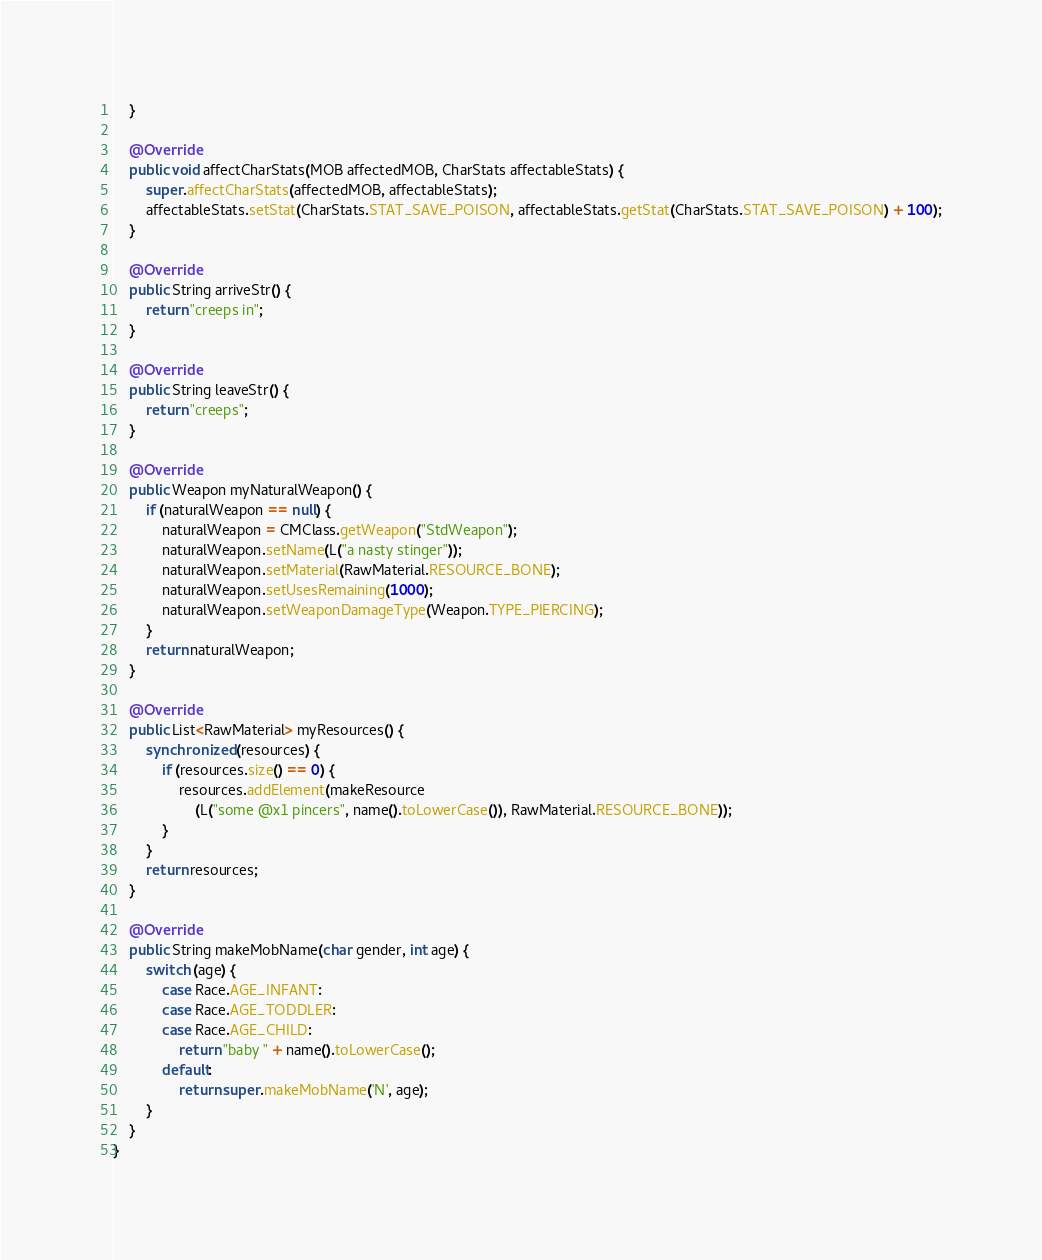<code> <loc_0><loc_0><loc_500><loc_500><_Java_>    }

    @Override
    public void affectCharStats(MOB affectedMOB, CharStats affectableStats) {
        super.affectCharStats(affectedMOB, affectableStats);
        affectableStats.setStat(CharStats.STAT_SAVE_POISON, affectableStats.getStat(CharStats.STAT_SAVE_POISON) + 100);
    }

    @Override
    public String arriveStr() {
        return "creeps in";
    }

    @Override
    public String leaveStr() {
        return "creeps";
    }

    @Override
    public Weapon myNaturalWeapon() {
        if (naturalWeapon == null) {
            naturalWeapon = CMClass.getWeapon("StdWeapon");
            naturalWeapon.setName(L("a nasty stinger"));
            naturalWeapon.setMaterial(RawMaterial.RESOURCE_BONE);
            naturalWeapon.setUsesRemaining(1000);
            naturalWeapon.setWeaponDamageType(Weapon.TYPE_PIERCING);
        }
        return naturalWeapon;
    }

    @Override
    public List<RawMaterial> myResources() {
        synchronized (resources) {
            if (resources.size() == 0) {
                resources.addElement(makeResource
                    (L("some @x1 pincers", name().toLowerCase()), RawMaterial.RESOURCE_BONE));
            }
        }
        return resources;
    }

    @Override
    public String makeMobName(char gender, int age) {
        switch (age) {
            case Race.AGE_INFANT:
            case Race.AGE_TODDLER:
            case Race.AGE_CHILD:
                return "baby " + name().toLowerCase();
            default:
                return super.makeMobName('N', age);
        }
    }
}
</code> 